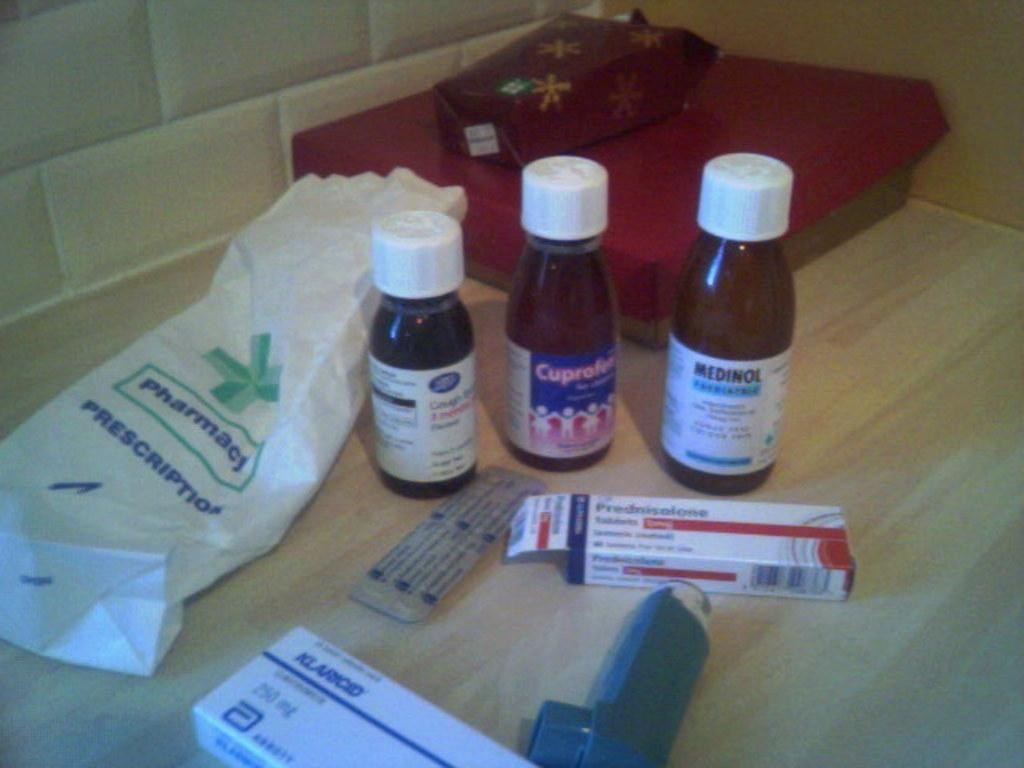Provide a one-sentence caption for the provided image. A bunch of different medicines from a pharmacy's perscription bag. 